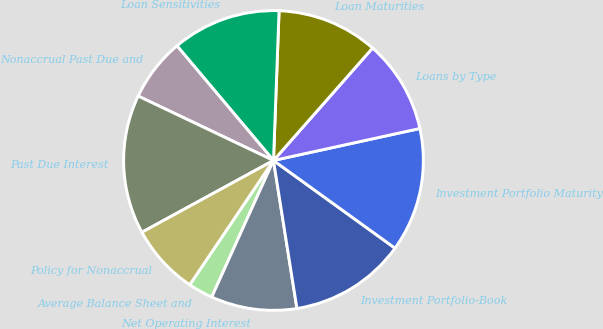Convert chart. <chart><loc_0><loc_0><loc_500><loc_500><pie_chart><fcel>Average Balance Sheet and<fcel>Net Operating Interest<fcel>Investment Portfolio-Book<fcel>Investment Portfolio Maturity<fcel>Loans by Type<fcel>Loan Maturities<fcel>Loan Sensitivities<fcel>Nonaccrual Past Due and<fcel>Past Due Interest<fcel>Policy for Nonaccrual<nl><fcel>2.68%<fcel>9.26%<fcel>12.55%<fcel>13.37%<fcel>10.08%<fcel>10.9%<fcel>11.73%<fcel>6.79%<fcel>15.02%<fcel>7.61%<nl></chart> 